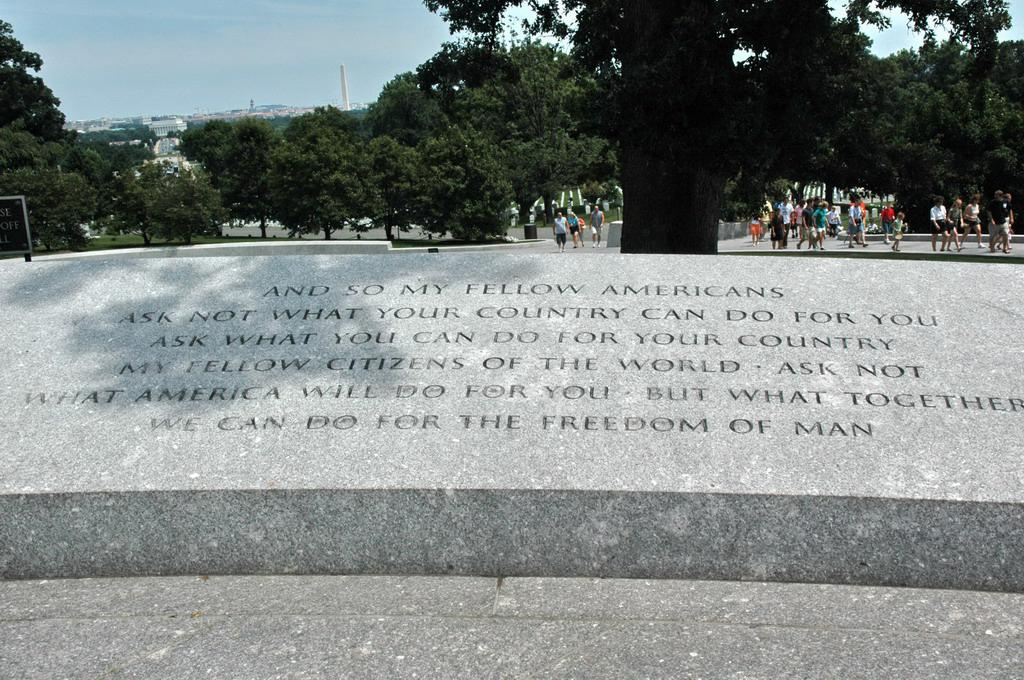What is written or displayed on the wall in the image? There is text on the wall in the image. What are the people in the image doing? The people in the image are walking on a path. What type of vegetation can be seen in the image? There are trees in the image. What type of structures are visible in the image? There are buildings in the image. What can be seen in the background of the image? The sky is visible in the background of the image. Can you tell me how many times the word "existence" appears in the text on the wall? There is no information about the specific text on the wall, so it is impossible to determine how many times the word "existence" appears. What is the condition of the people's throats in the image? There is no information about the people's throats in the image, so it is impossible to determine their condition. 